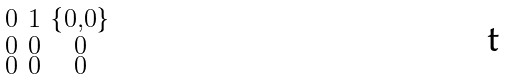<formula> <loc_0><loc_0><loc_500><loc_500>\begin{smallmatrix} 0 & 1 & \{ 0 , 0 \} \\ 0 & 0 & 0 \\ 0 & 0 & 0 \end{smallmatrix}</formula> 